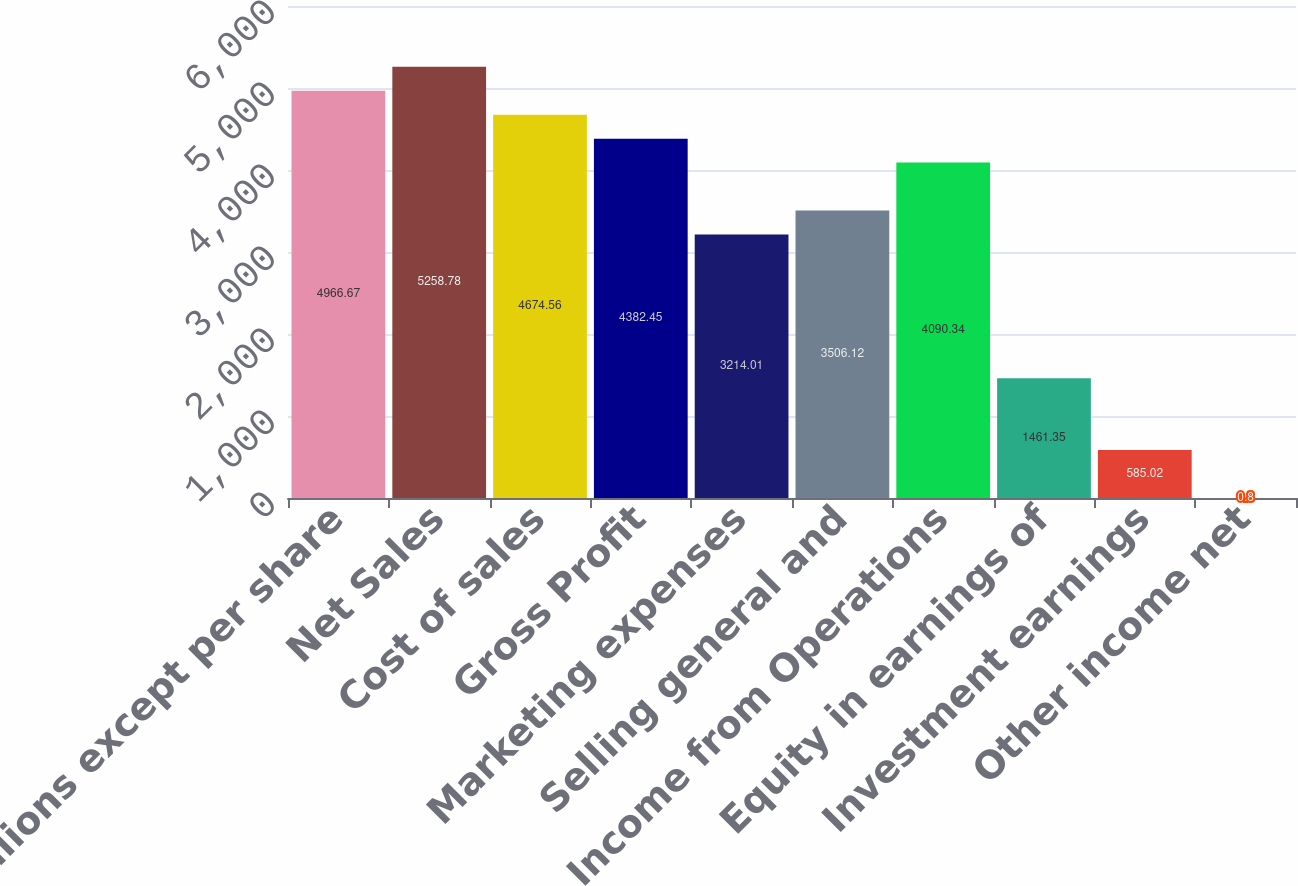<chart> <loc_0><loc_0><loc_500><loc_500><bar_chart><fcel>(In millions except per share<fcel>Net Sales<fcel>Cost of sales<fcel>Gross Profit<fcel>Marketing expenses<fcel>Selling general and<fcel>Income from Operations<fcel>Equity in earnings of<fcel>Investment earnings<fcel>Other income net<nl><fcel>4966.67<fcel>5258.78<fcel>4674.56<fcel>4382.45<fcel>3214.01<fcel>3506.12<fcel>4090.34<fcel>1461.35<fcel>585.02<fcel>0.8<nl></chart> 